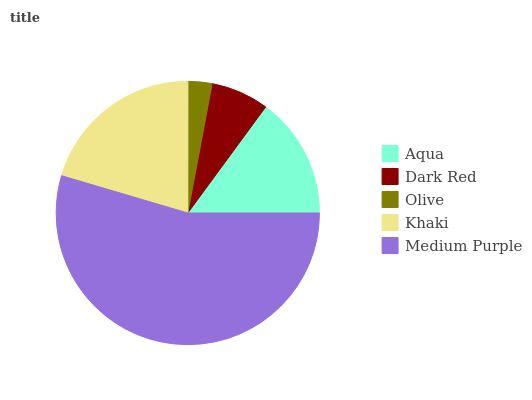Is Olive the minimum?
Answer yes or no. Yes. Is Medium Purple the maximum?
Answer yes or no. Yes. Is Dark Red the minimum?
Answer yes or no. No. Is Dark Red the maximum?
Answer yes or no. No. Is Aqua greater than Dark Red?
Answer yes or no. Yes. Is Dark Red less than Aqua?
Answer yes or no. Yes. Is Dark Red greater than Aqua?
Answer yes or no. No. Is Aqua less than Dark Red?
Answer yes or no. No. Is Aqua the high median?
Answer yes or no. Yes. Is Aqua the low median?
Answer yes or no. Yes. Is Olive the high median?
Answer yes or no. No. Is Dark Red the low median?
Answer yes or no. No. 